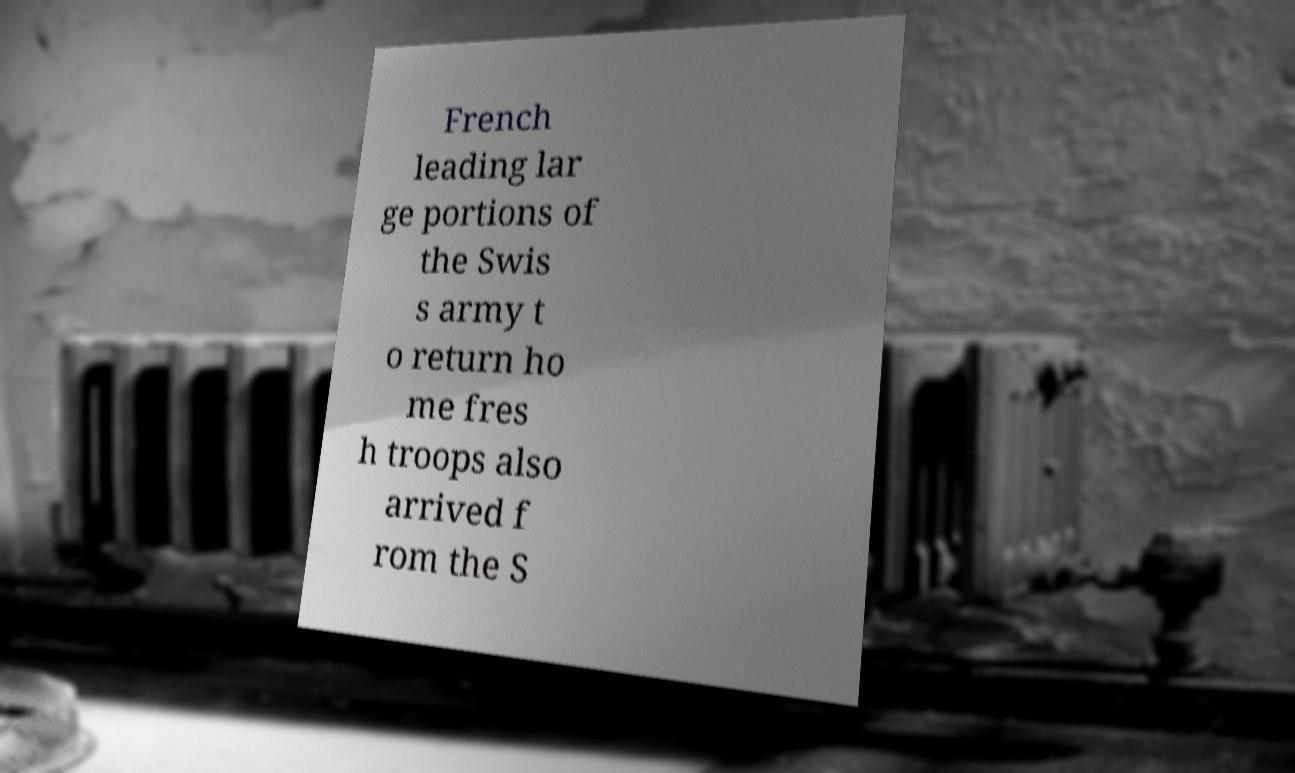I need the written content from this picture converted into text. Can you do that? French leading lar ge portions of the Swis s army t o return ho me fres h troops also arrived f rom the S 